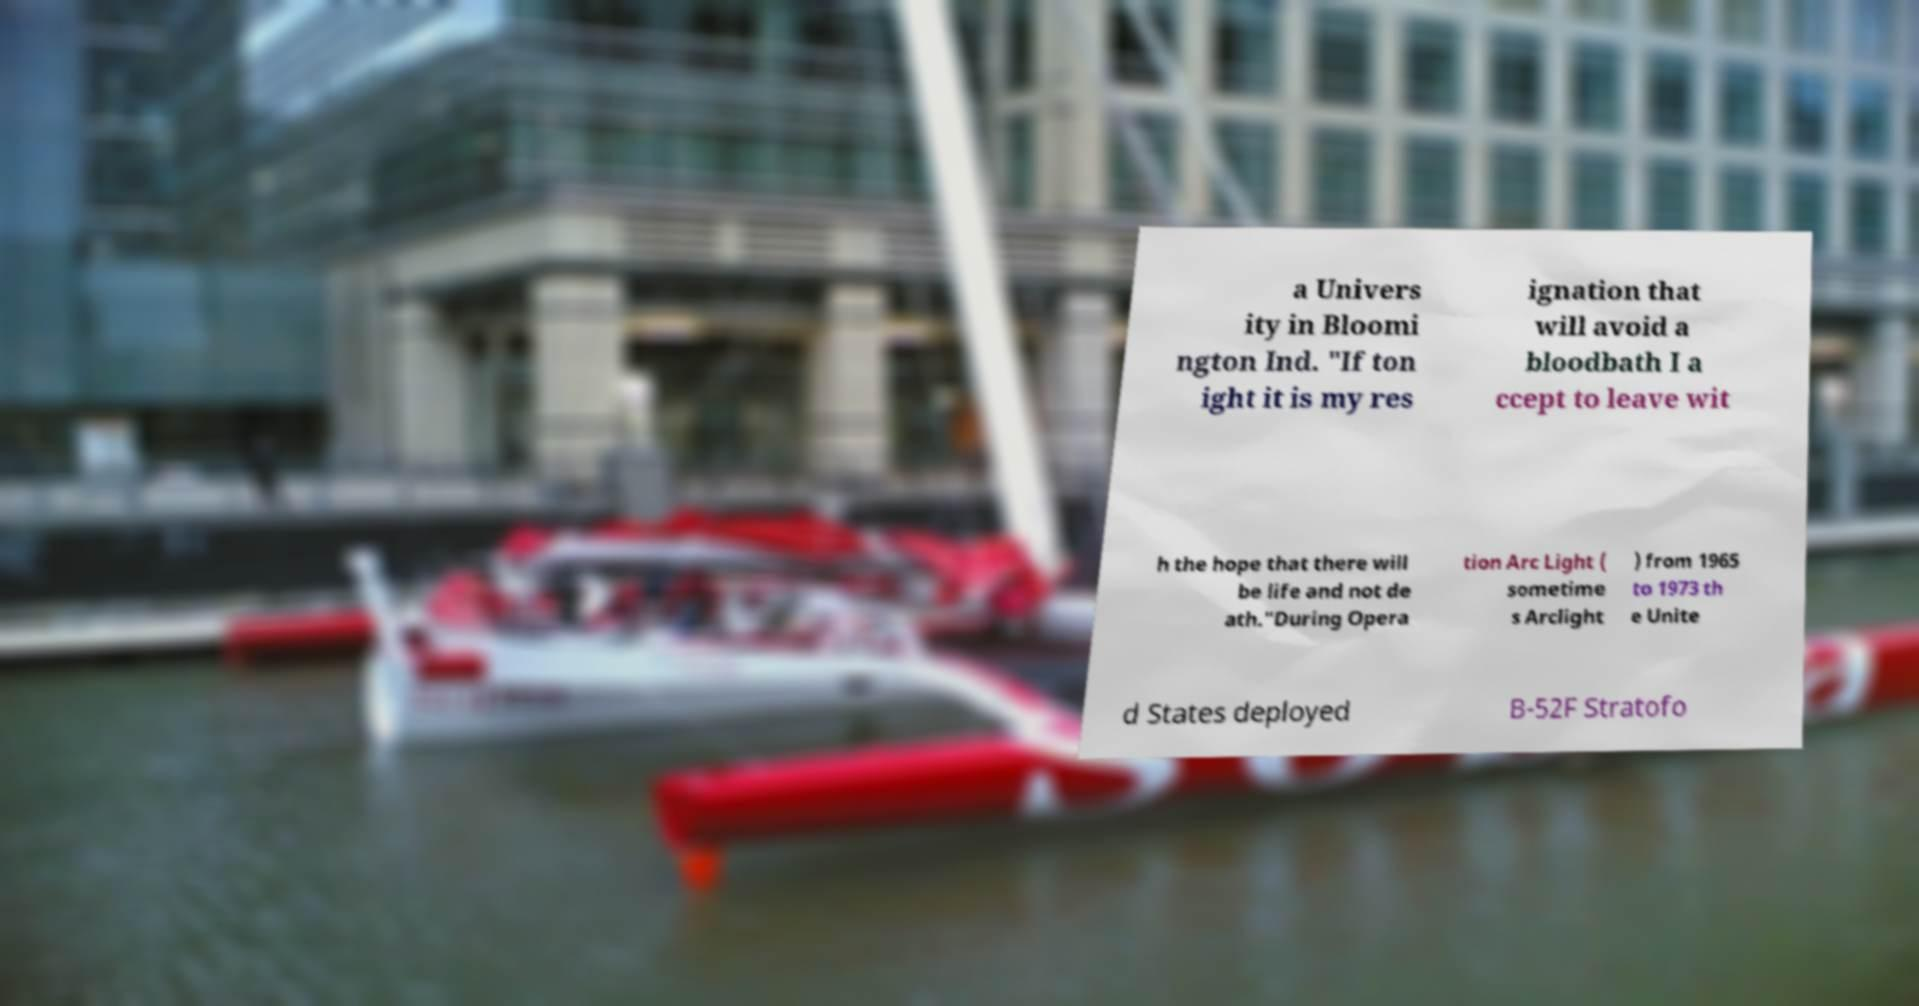Please read and relay the text visible in this image. What does it say? a Univers ity in Bloomi ngton Ind. "If ton ight it is my res ignation that will avoid a bloodbath I a ccept to leave wit h the hope that there will be life and not de ath."During Opera tion Arc Light ( sometime s Arclight ) from 1965 to 1973 th e Unite d States deployed B-52F Stratofo 